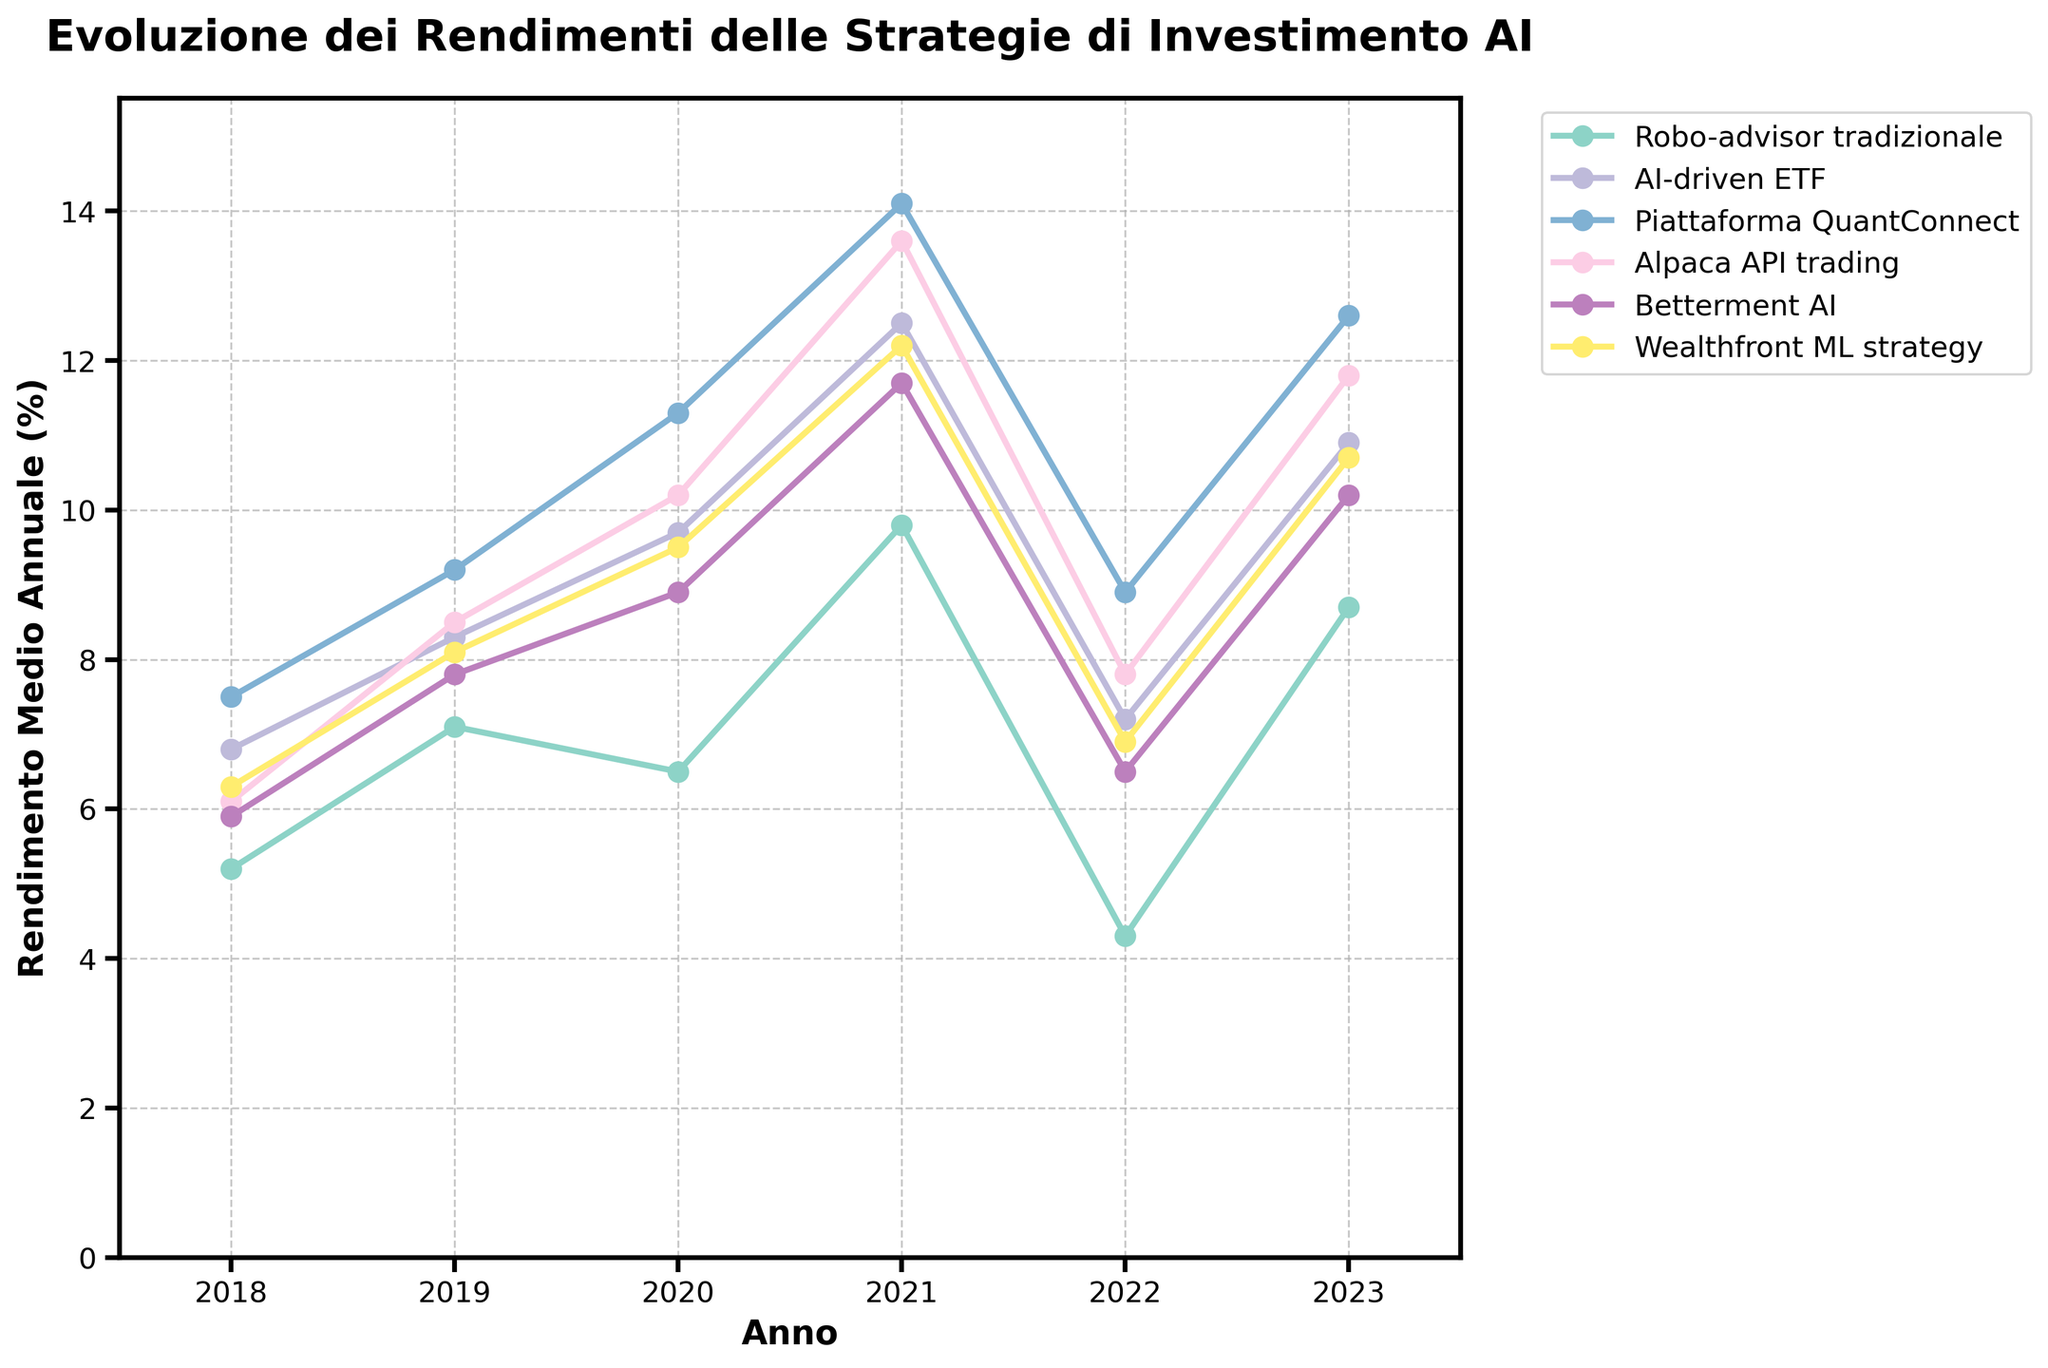What's the average rendimento medio annuale for the AI-driven ETF from 2018 to 2023? First, we sum the rendimenti for AI-driven ETF: 6.8 + 8.3 + 9.7 + 12.5 + 7.2 + 10.9 = 55.4. Then, we divide by the number of years, which is 6. Therefore, the average is 55.4 / 6.
Answer: 9.23 Which strategy had the highest rendimento medio annuale in 2021? In 2021, the rendimenti are 9.8 (Robo-advisor tradizionale), 12.5 (AI-driven ETF), 14.1 (Piattaforma QuantConnect), 13.6 (Alpaca API trading), 11.7 (Betterment AI), and 12.2 (Wealthfront ML strategy). The highest rendimento is for Piattaforma QuantConnect with 14.1.
Answer: Piattaforma QuantConnect What is the difference in rendimento medio annuale between Alpaca API trading and Betterment AI in 2023? The rendimento for Alpaca API trading in 2023 is 11.8 and for Betterment AI is 10.2. The difference is 11.8 - 10.2 = 1.6.
Answer: 1.6 Did any strategy have a rendimento medio annuale lower than 5% in any year? Check each series across all years. The only value lower than 5% is for Robo-advisor tradizionale in 2022 with 4.3.
Answer: Yes, Robo-advisor tradizionale in 2022 What is the combined rendimento medio annuale for the AI institutions (AI-driven ETF, Piattaforma QuantConnect, Betterment AI, and Wealthfront ML strategy) in 2023? Sum the rendimenti for 2023 for AI-driven ETF (10.9), Piattaforma QuantConnect (12.6), Betterment AI (10.2), and Wealthfront ML strategy (10.7). The combined rendimento is 10.9 + 12.6 + 10.2 + 10.7 = 44.4.
Answer: 44.4 How did the rendimento medio annuale for Wealthfront ML strategy change from 2019 to 2020? In 2019, Wealthfront ML strategy's rendimento was 8.1. In 2020, it was 9.5. The change is 9.5 - 8.1 = 1.4.
Answer: Increased by 1.4 Which year did Piattaforma QuantConnect have the least rendimento medio annuale? The rendimenti for Piattaforma QuantConnect are 7.5 (2018), 9.2 (2019), 11.3 (2020), 14.1 (2021), 8.9 (2022), and 12.6 (2023). The least rendimento is 7.5 in 2018.
Answer: 2018 